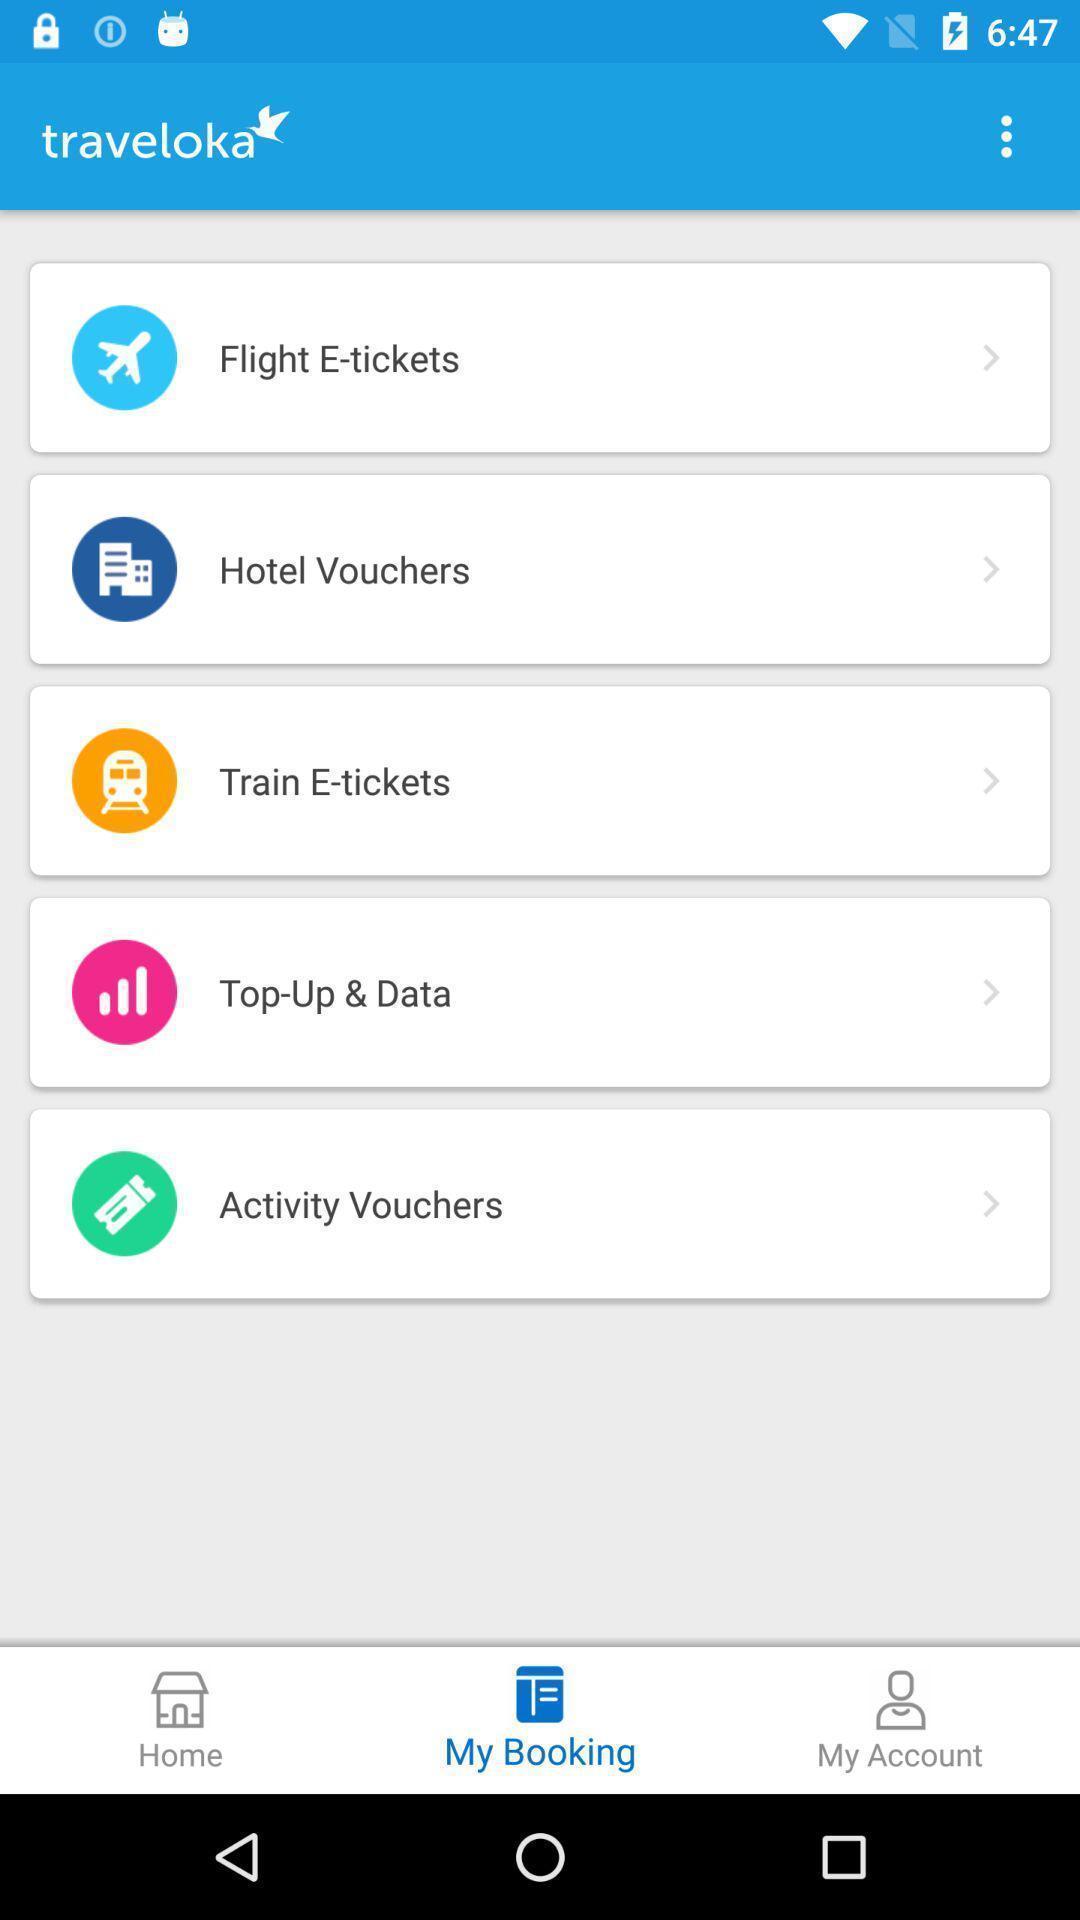What can you discern from this picture? Screen shows multiple options in a travel application. Explain what's happening in this screen capture. Page shows different options in an service application. 